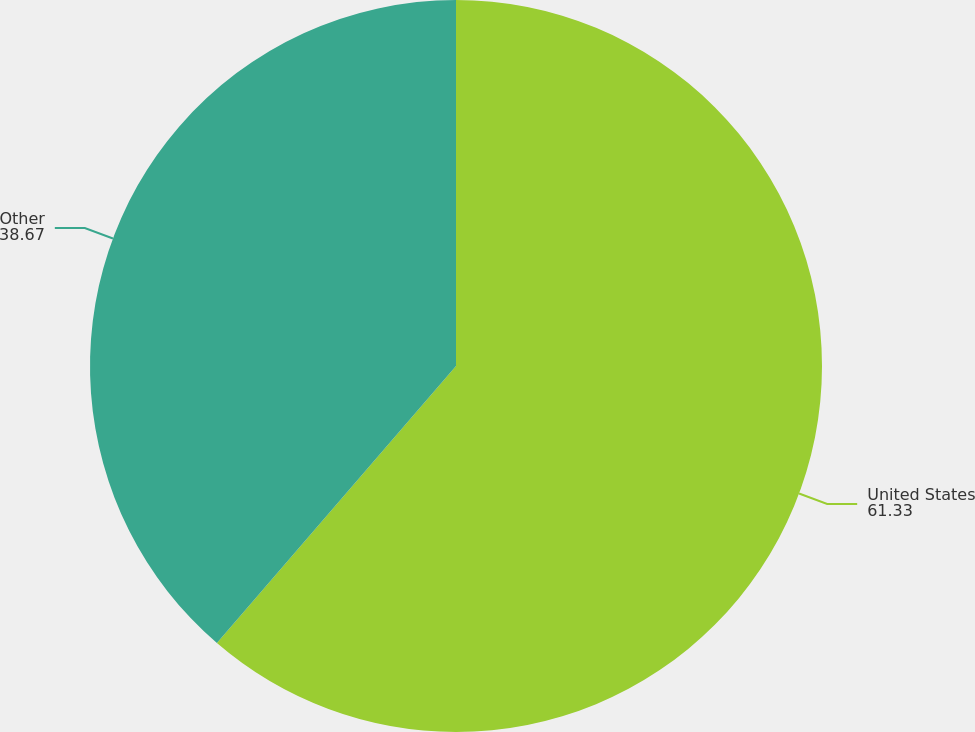Convert chart. <chart><loc_0><loc_0><loc_500><loc_500><pie_chart><fcel>United States<fcel>Other<nl><fcel>61.33%<fcel>38.67%<nl></chart> 